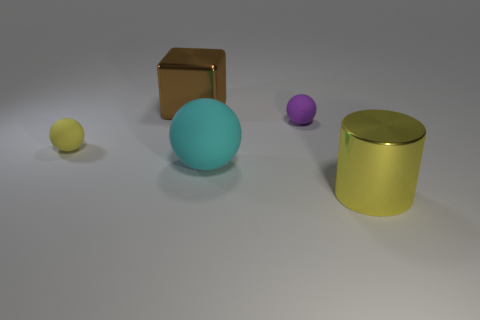There is a tiny thing that is the same color as the large metallic cylinder; what is its material?
Keep it short and to the point. Rubber. What number of other objects are the same color as the big shiny cylinder?
Give a very brief answer. 1. What shape is the tiny purple thing that is made of the same material as the large cyan thing?
Keep it short and to the point. Sphere. Is there anything else that has the same shape as the brown object?
Your response must be concise. No. Is the tiny ball that is to the left of the purple rubber object made of the same material as the big brown object?
Your answer should be very brief. No. What is the tiny object that is left of the purple ball made of?
Offer a very short reply. Rubber. What is the size of the yellow object left of the large object that is right of the large cyan sphere?
Provide a succinct answer. Small. How many yellow balls have the same size as the brown block?
Offer a very short reply. 0. Do the metal thing that is behind the cylinder and the tiny ball to the left of the big rubber thing have the same color?
Provide a short and direct response. No. There is a big yellow metallic cylinder; are there any big yellow shiny objects right of it?
Offer a very short reply. No. 